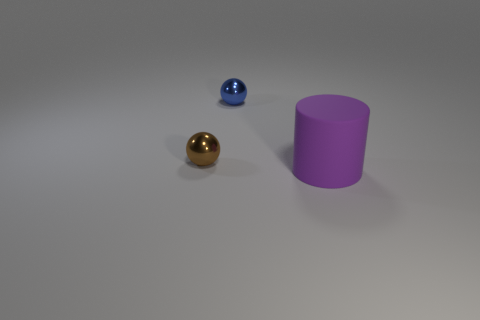Add 3 tiny brown metallic objects. How many objects exist? 6 Subtract all spheres. How many objects are left? 1 Subtract all big rubber objects. Subtract all tiny objects. How many objects are left? 0 Add 3 purple matte cylinders. How many purple matte cylinders are left? 4 Add 2 small brown metallic balls. How many small brown metallic balls exist? 3 Subtract 0 yellow cubes. How many objects are left? 3 